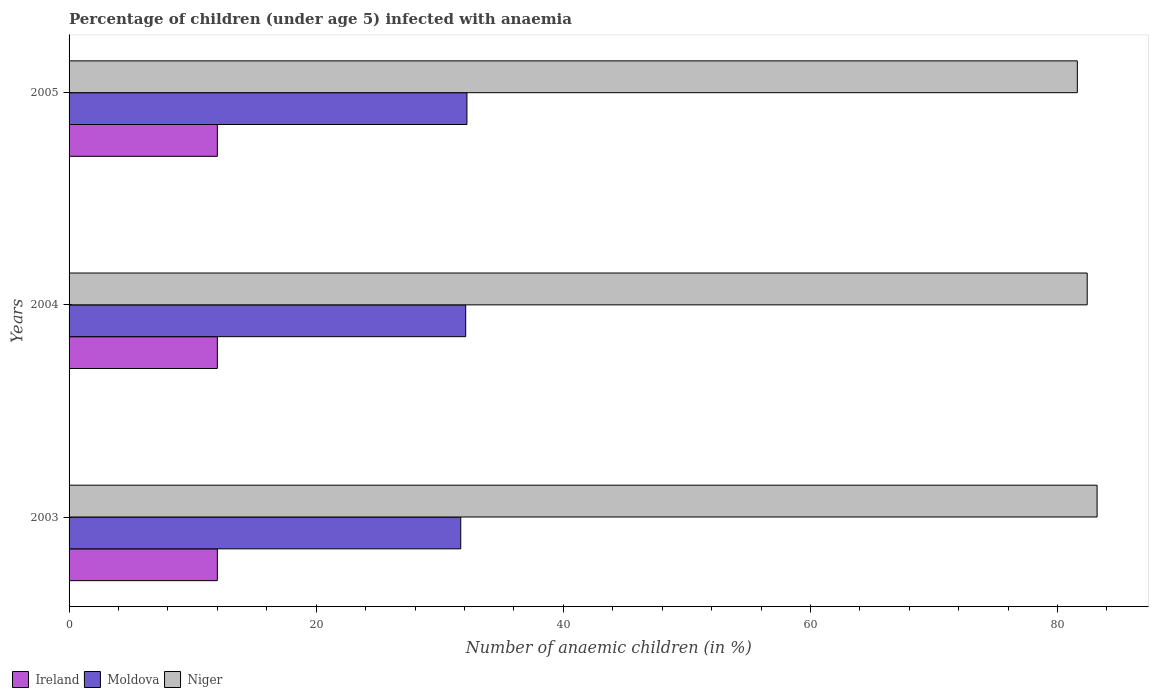How many different coloured bars are there?
Ensure brevity in your answer.  3. Are the number of bars per tick equal to the number of legend labels?
Provide a short and direct response. Yes. How many bars are there on the 3rd tick from the top?
Your response must be concise. 3. In how many cases, is the number of bars for a given year not equal to the number of legend labels?
Offer a terse response. 0. What is the percentage of children infected with anaemia in in Niger in 2005?
Make the answer very short. 81.6. Across all years, what is the maximum percentage of children infected with anaemia in in Niger?
Keep it short and to the point. 83.2. Across all years, what is the minimum percentage of children infected with anaemia in in Moldova?
Your response must be concise. 31.7. In which year was the percentage of children infected with anaemia in in Ireland minimum?
Make the answer very short. 2003. What is the total percentage of children infected with anaemia in in Moldova in the graph?
Provide a short and direct response. 96. What is the difference between the percentage of children infected with anaemia in in Niger in 2003 and that in 2004?
Provide a succinct answer. 0.8. What is the difference between the percentage of children infected with anaemia in in Niger in 2004 and the percentage of children infected with anaemia in in Ireland in 2005?
Offer a terse response. 70.4. What is the average percentage of children infected with anaemia in in Ireland per year?
Your answer should be compact. 12. In the year 2003, what is the difference between the percentage of children infected with anaemia in in Niger and percentage of children infected with anaemia in in Ireland?
Your answer should be compact. 71.2. In how many years, is the percentage of children infected with anaemia in in Niger greater than 60 %?
Give a very brief answer. 3. What is the ratio of the percentage of children infected with anaemia in in Moldova in 2003 to that in 2005?
Your answer should be very brief. 0.98. What is the difference between the highest and the second highest percentage of children infected with anaemia in in Ireland?
Keep it short and to the point. 0. What is the difference between the highest and the lowest percentage of children infected with anaemia in in Moldova?
Give a very brief answer. 0.5. What does the 2nd bar from the top in 2004 represents?
Your answer should be very brief. Moldova. What does the 3rd bar from the bottom in 2004 represents?
Ensure brevity in your answer.  Niger. Are all the bars in the graph horizontal?
Provide a succinct answer. Yes. How many years are there in the graph?
Make the answer very short. 3. Does the graph contain any zero values?
Keep it short and to the point. No. How many legend labels are there?
Provide a succinct answer. 3. What is the title of the graph?
Offer a terse response. Percentage of children (under age 5) infected with anaemia. What is the label or title of the X-axis?
Provide a short and direct response. Number of anaemic children (in %). What is the Number of anaemic children (in %) in Moldova in 2003?
Your response must be concise. 31.7. What is the Number of anaemic children (in %) of Niger in 2003?
Your response must be concise. 83.2. What is the Number of anaemic children (in %) in Moldova in 2004?
Your response must be concise. 32.1. What is the Number of anaemic children (in %) in Niger in 2004?
Keep it short and to the point. 82.4. What is the Number of anaemic children (in %) in Moldova in 2005?
Offer a very short reply. 32.2. What is the Number of anaemic children (in %) of Niger in 2005?
Your answer should be compact. 81.6. Across all years, what is the maximum Number of anaemic children (in %) of Moldova?
Provide a short and direct response. 32.2. Across all years, what is the maximum Number of anaemic children (in %) in Niger?
Your response must be concise. 83.2. Across all years, what is the minimum Number of anaemic children (in %) of Moldova?
Your answer should be compact. 31.7. Across all years, what is the minimum Number of anaemic children (in %) of Niger?
Your answer should be very brief. 81.6. What is the total Number of anaemic children (in %) in Ireland in the graph?
Provide a short and direct response. 36. What is the total Number of anaemic children (in %) in Moldova in the graph?
Your answer should be very brief. 96. What is the total Number of anaemic children (in %) of Niger in the graph?
Keep it short and to the point. 247.2. What is the difference between the Number of anaemic children (in %) of Ireland in 2003 and that in 2004?
Provide a succinct answer. 0. What is the difference between the Number of anaemic children (in %) in Niger in 2003 and that in 2005?
Ensure brevity in your answer.  1.6. What is the difference between the Number of anaemic children (in %) in Ireland in 2004 and that in 2005?
Provide a short and direct response. 0. What is the difference between the Number of anaemic children (in %) in Ireland in 2003 and the Number of anaemic children (in %) in Moldova in 2004?
Give a very brief answer. -20.1. What is the difference between the Number of anaemic children (in %) of Ireland in 2003 and the Number of anaemic children (in %) of Niger in 2004?
Ensure brevity in your answer.  -70.4. What is the difference between the Number of anaemic children (in %) in Moldova in 2003 and the Number of anaemic children (in %) in Niger in 2004?
Provide a short and direct response. -50.7. What is the difference between the Number of anaemic children (in %) in Ireland in 2003 and the Number of anaemic children (in %) in Moldova in 2005?
Your answer should be compact. -20.2. What is the difference between the Number of anaemic children (in %) of Ireland in 2003 and the Number of anaemic children (in %) of Niger in 2005?
Provide a succinct answer. -69.6. What is the difference between the Number of anaemic children (in %) in Moldova in 2003 and the Number of anaemic children (in %) in Niger in 2005?
Make the answer very short. -49.9. What is the difference between the Number of anaemic children (in %) of Ireland in 2004 and the Number of anaemic children (in %) of Moldova in 2005?
Provide a succinct answer. -20.2. What is the difference between the Number of anaemic children (in %) in Ireland in 2004 and the Number of anaemic children (in %) in Niger in 2005?
Provide a succinct answer. -69.6. What is the difference between the Number of anaemic children (in %) of Moldova in 2004 and the Number of anaemic children (in %) of Niger in 2005?
Make the answer very short. -49.5. What is the average Number of anaemic children (in %) in Ireland per year?
Your answer should be very brief. 12. What is the average Number of anaemic children (in %) in Moldova per year?
Offer a terse response. 32. What is the average Number of anaemic children (in %) in Niger per year?
Give a very brief answer. 82.4. In the year 2003, what is the difference between the Number of anaemic children (in %) in Ireland and Number of anaemic children (in %) in Moldova?
Provide a succinct answer. -19.7. In the year 2003, what is the difference between the Number of anaemic children (in %) in Ireland and Number of anaemic children (in %) in Niger?
Make the answer very short. -71.2. In the year 2003, what is the difference between the Number of anaemic children (in %) of Moldova and Number of anaemic children (in %) of Niger?
Ensure brevity in your answer.  -51.5. In the year 2004, what is the difference between the Number of anaemic children (in %) in Ireland and Number of anaemic children (in %) in Moldova?
Make the answer very short. -20.1. In the year 2004, what is the difference between the Number of anaemic children (in %) in Ireland and Number of anaemic children (in %) in Niger?
Offer a terse response. -70.4. In the year 2004, what is the difference between the Number of anaemic children (in %) of Moldova and Number of anaemic children (in %) of Niger?
Your answer should be very brief. -50.3. In the year 2005, what is the difference between the Number of anaemic children (in %) of Ireland and Number of anaemic children (in %) of Moldova?
Offer a very short reply. -20.2. In the year 2005, what is the difference between the Number of anaemic children (in %) in Ireland and Number of anaemic children (in %) in Niger?
Offer a terse response. -69.6. In the year 2005, what is the difference between the Number of anaemic children (in %) of Moldova and Number of anaemic children (in %) of Niger?
Provide a succinct answer. -49.4. What is the ratio of the Number of anaemic children (in %) in Moldova in 2003 to that in 2004?
Provide a succinct answer. 0.99. What is the ratio of the Number of anaemic children (in %) in Niger in 2003 to that in 2004?
Your answer should be compact. 1.01. What is the ratio of the Number of anaemic children (in %) of Moldova in 2003 to that in 2005?
Your answer should be compact. 0.98. What is the ratio of the Number of anaemic children (in %) of Niger in 2003 to that in 2005?
Give a very brief answer. 1.02. What is the ratio of the Number of anaemic children (in %) of Ireland in 2004 to that in 2005?
Your response must be concise. 1. What is the ratio of the Number of anaemic children (in %) in Moldova in 2004 to that in 2005?
Your answer should be very brief. 1. What is the ratio of the Number of anaemic children (in %) of Niger in 2004 to that in 2005?
Offer a very short reply. 1.01. What is the difference between the highest and the second highest Number of anaemic children (in %) of Ireland?
Offer a very short reply. 0. What is the difference between the highest and the second highest Number of anaemic children (in %) of Niger?
Give a very brief answer. 0.8. What is the difference between the highest and the lowest Number of anaemic children (in %) of Ireland?
Give a very brief answer. 0. What is the difference between the highest and the lowest Number of anaemic children (in %) in Moldova?
Provide a short and direct response. 0.5. 